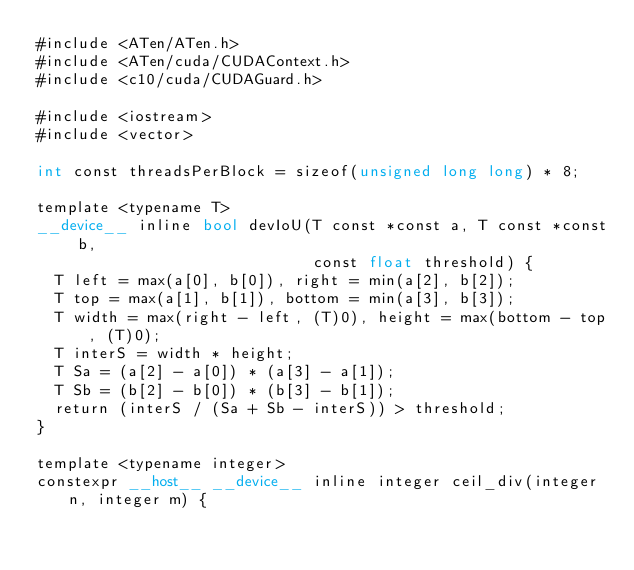Convert code to text. <code><loc_0><loc_0><loc_500><loc_500><_Cuda_>#include <ATen/ATen.h>
#include <ATen/cuda/CUDAContext.h>
#include <c10/cuda/CUDAGuard.h>

#include <iostream>
#include <vector>

int const threadsPerBlock = sizeof(unsigned long long) * 8;

template <typename T>
__device__ inline bool devIoU(T const *const a, T const *const b,
                              const float threshold) {
  T left = max(a[0], b[0]), right = min(a[2], b[2]);
  T top = max(a[1], b[1]), bottom = min(a[3], b[3]);
  T width = max(right - left, (T)0), height = max(bottom - top, (T)0);
  T interS = width * height;
  T Sa = (a[2] - a[0]) * (a[3] - a[1]);
  T Sb = (b[2] - b[0]) * (b[3] - b[1]);
  return (interS / (Sa + Sb - interS)) > threshold;
}

template <typename integer>
constexpr __host__ __device__ inline integer ceil_div(integer n, integer m) {</code> 